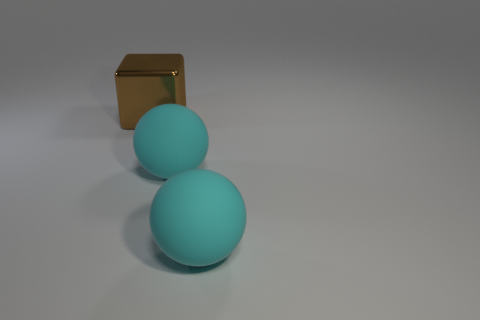Are there any large cyan objects?
Ensure brevity in your answer.  Yes. What number of other things are the same color as the big metal object?
Ensure brevity in your answer.  0. How many things are either brown metal blocks or things in front of the block?
Offer a terse response. 3. There is a large brown shiny thing; what shape is it?
Give a very brief answer. Cube. What number of other things are made of the same material as the big block?
Give a very brief answer. 0. How many rubber balls have the same size as the brown block?
Give a very brief answer. 2. Are there more big cyan matte objects than large things?
Your answer should be very brief. No. Are there fewer small cyan rubber cylinders than cyan matte objects?
Offer a terse response. Yes. How many cyan things are rubber objects or large cubes?
Your answer should be very brief. 2. Are there any other things that have the same shape as the brown thing?
Your answer should be compact. No. 